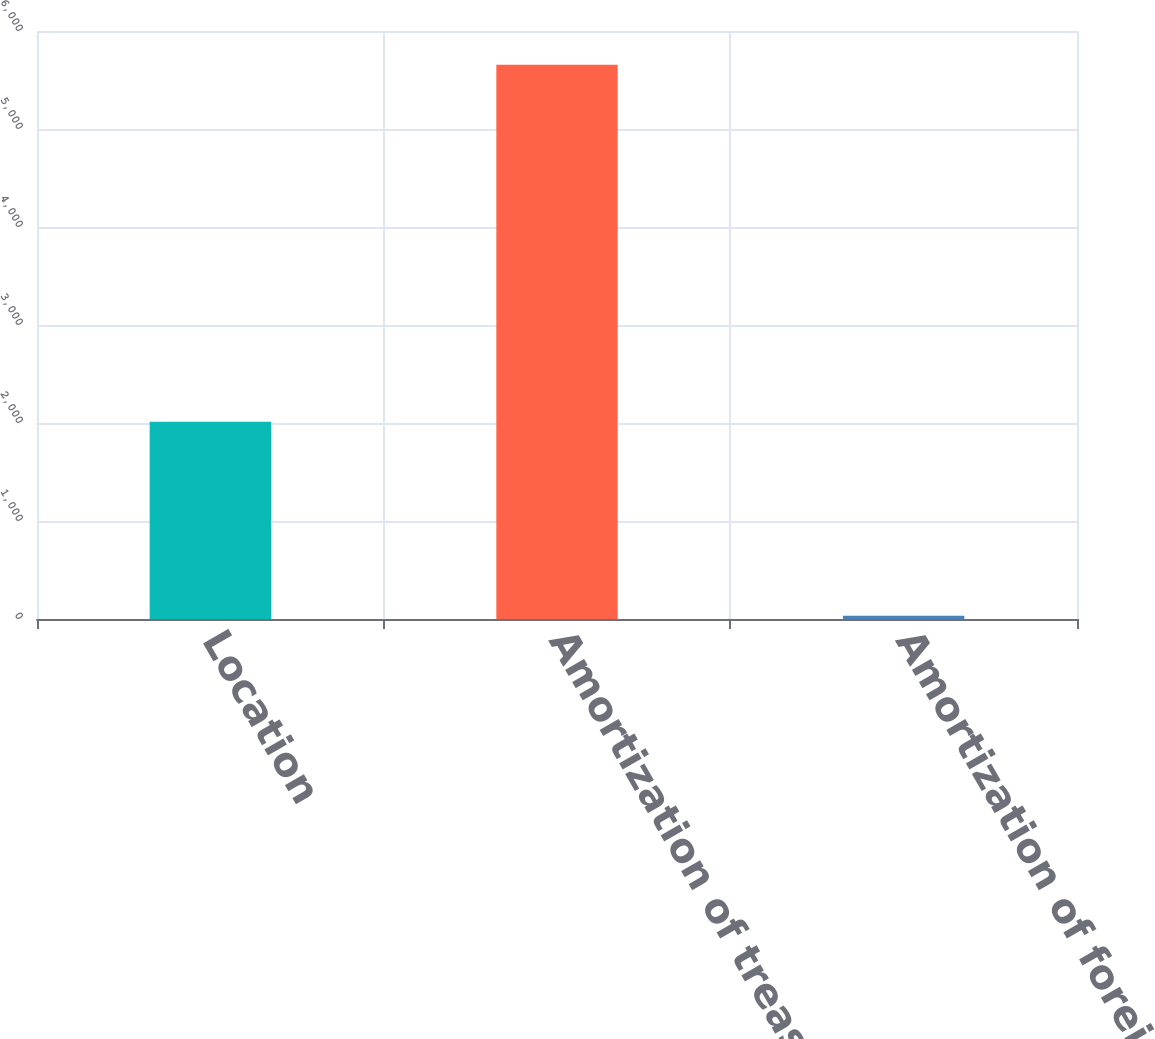Convert chart to OTSL. <chart><loc_0><loc_0><loc_500><loc_500><bar_chart><fcel>Location<fcel>Amortization of treasury locks<fcel>Amortization of foreign<nl><fcel>2013<fcel>5655<fcel>34<nl></chart> 